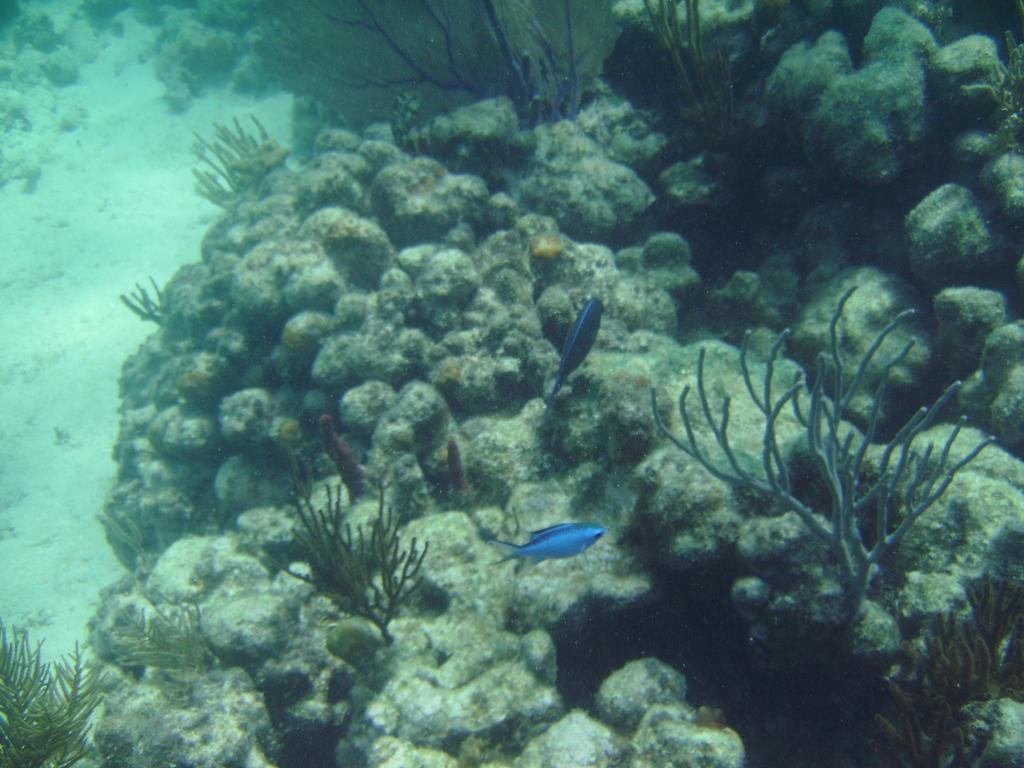What type of animals can be seen in the foreground of the image? There are fish in the foreground of the image. What else is present in the foreground of the image besides the fish? There are aquatic plants in the foreground of the image. Where are the fish and aquatic plants located in the image? Both the fish and aquatic plants are underwater. What type of dog can be seen wearing a mask in the image? There is no dog or mask present in the image; it features fish and aquatic plants underwater. 